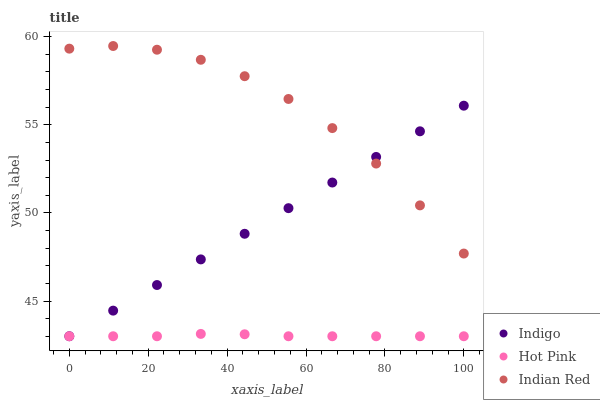Does Hot Pink have the minimum area under the curve?
Answer yes or no. Yes. Does Indian Red have the maximum area under the curve?
Answer yes or no. Yes. Does Indigo have the minimum area under the curve?
Answer yes or no. No. Does Indigo have the maximum area under the curve?
Answer yes or no. No. Is Indigo the smoothest?
Answer yes or no. Yes. Is Indian Red the roughest?
Answer yes or no. Yes. Is Indian Red the smoothest?
Answer yes or no. No. Is Indigo the roughest?
Answer yes or no. No. Does Hot Pink have the lowest value?
Answer yes or no. Yes. Does Indian Red have the lowest value?
Answer yes or no. No. Does Indian Red have the highest value?
Answer yes or no. Yes. Does Indigo have the highest value?
Answer yes or no. No. Is Hot Pink less than Indian Red?
Answer yes or no. Yes. Is Indian Red greater than Hot Pink?
Answer yes or no. Yes. Does Hot Pink intersect Indigo?
Answer yes or no. Yes. Is Hot Pink less than Indigo?
Answer yes or no. No. Is Hot Pink greater than Indigo?
Answer yes or no. No. Does Hot Pink intersect Indian Red?
Answer yes or no. No. 